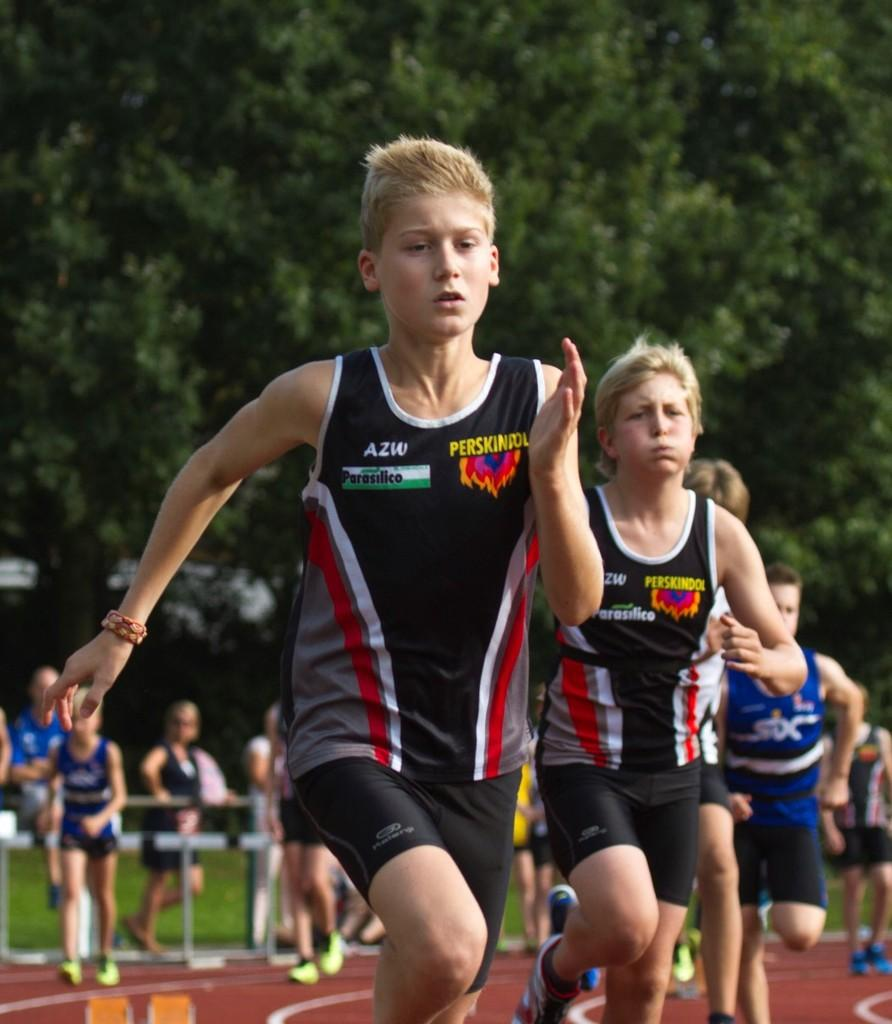Provide a one-sentence caption for the provided image. Several boys running on a track in jerseys that say Parasilico on them. 